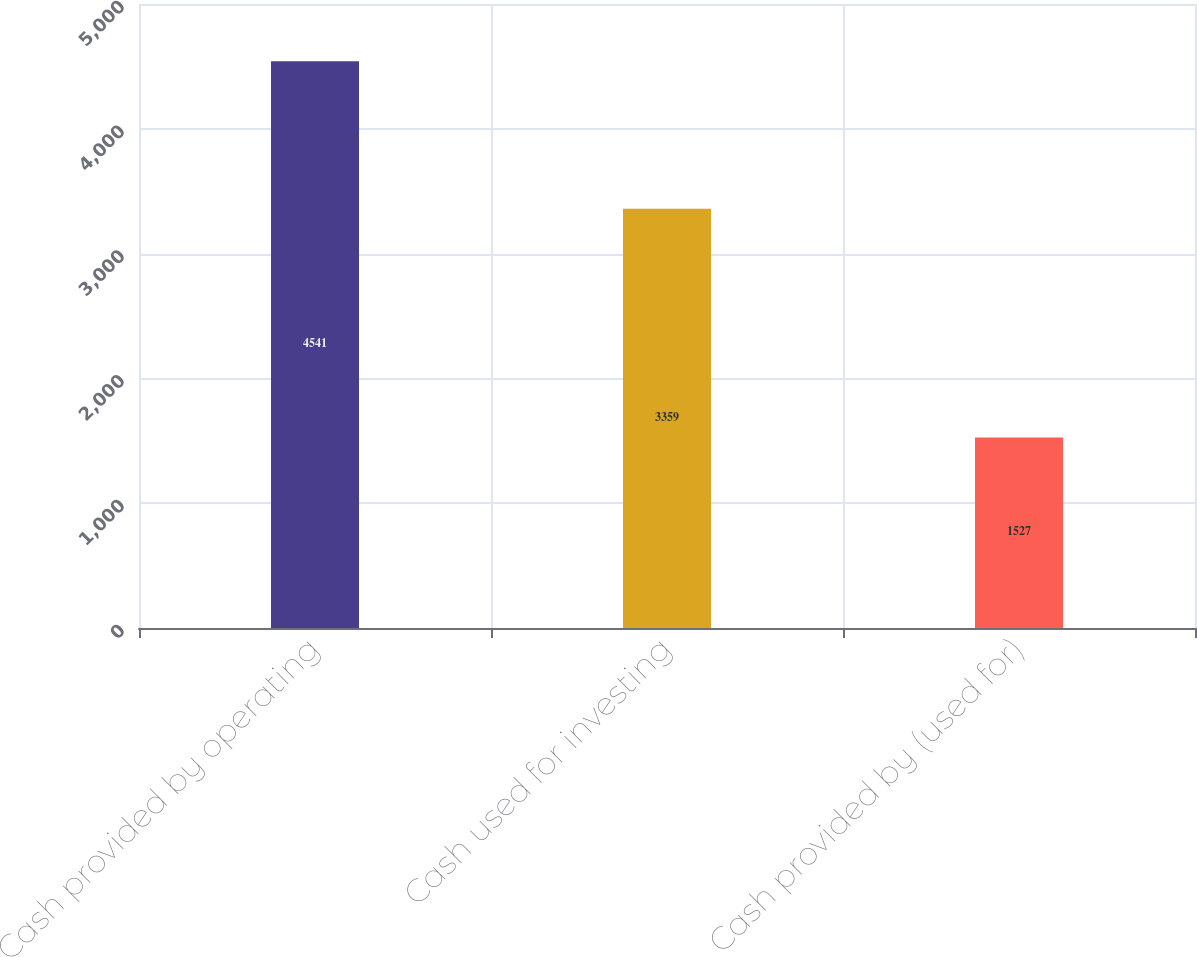Convert chart to OTSL. <chart><loc_0><loc_0><loc_500><loc_500><bar_chart><fcel>Cash provided by operating<fcel>Cash used for investing<fcel>Cash provided by (used for)<nl><fcel>4541<fcel>3359<fcel>1527<nl></chart> 